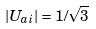<formula> <loc_0><loc_0><loc_500><loc_500>| U _ { a i } | = 1 / \sqrt { 3 }</formula> 